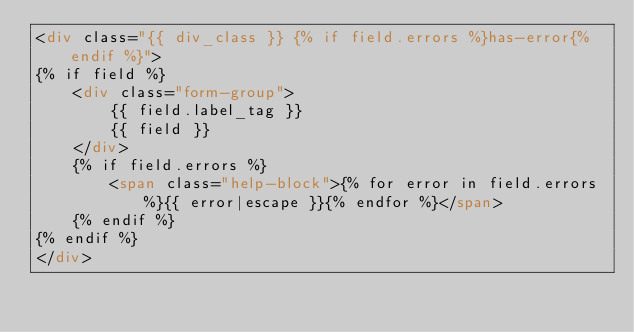Convert code to text. <code><loc_0><loc_0><loc_500><loc_500><_HTML_><div class="{{ div_class }} {% if field.errors %}has-error{% endif %}">
{% if field %}    
    <div class="form-group">
        {{ field.label_tag }}
        {{ field }}
    </div>
    {% if field.errors %}
        <span class="help-block">{% for error in field.errors %}{{ error|escape }}{% endfor %}</span>
    {% endif %}
{% endif %}
</div></code> 